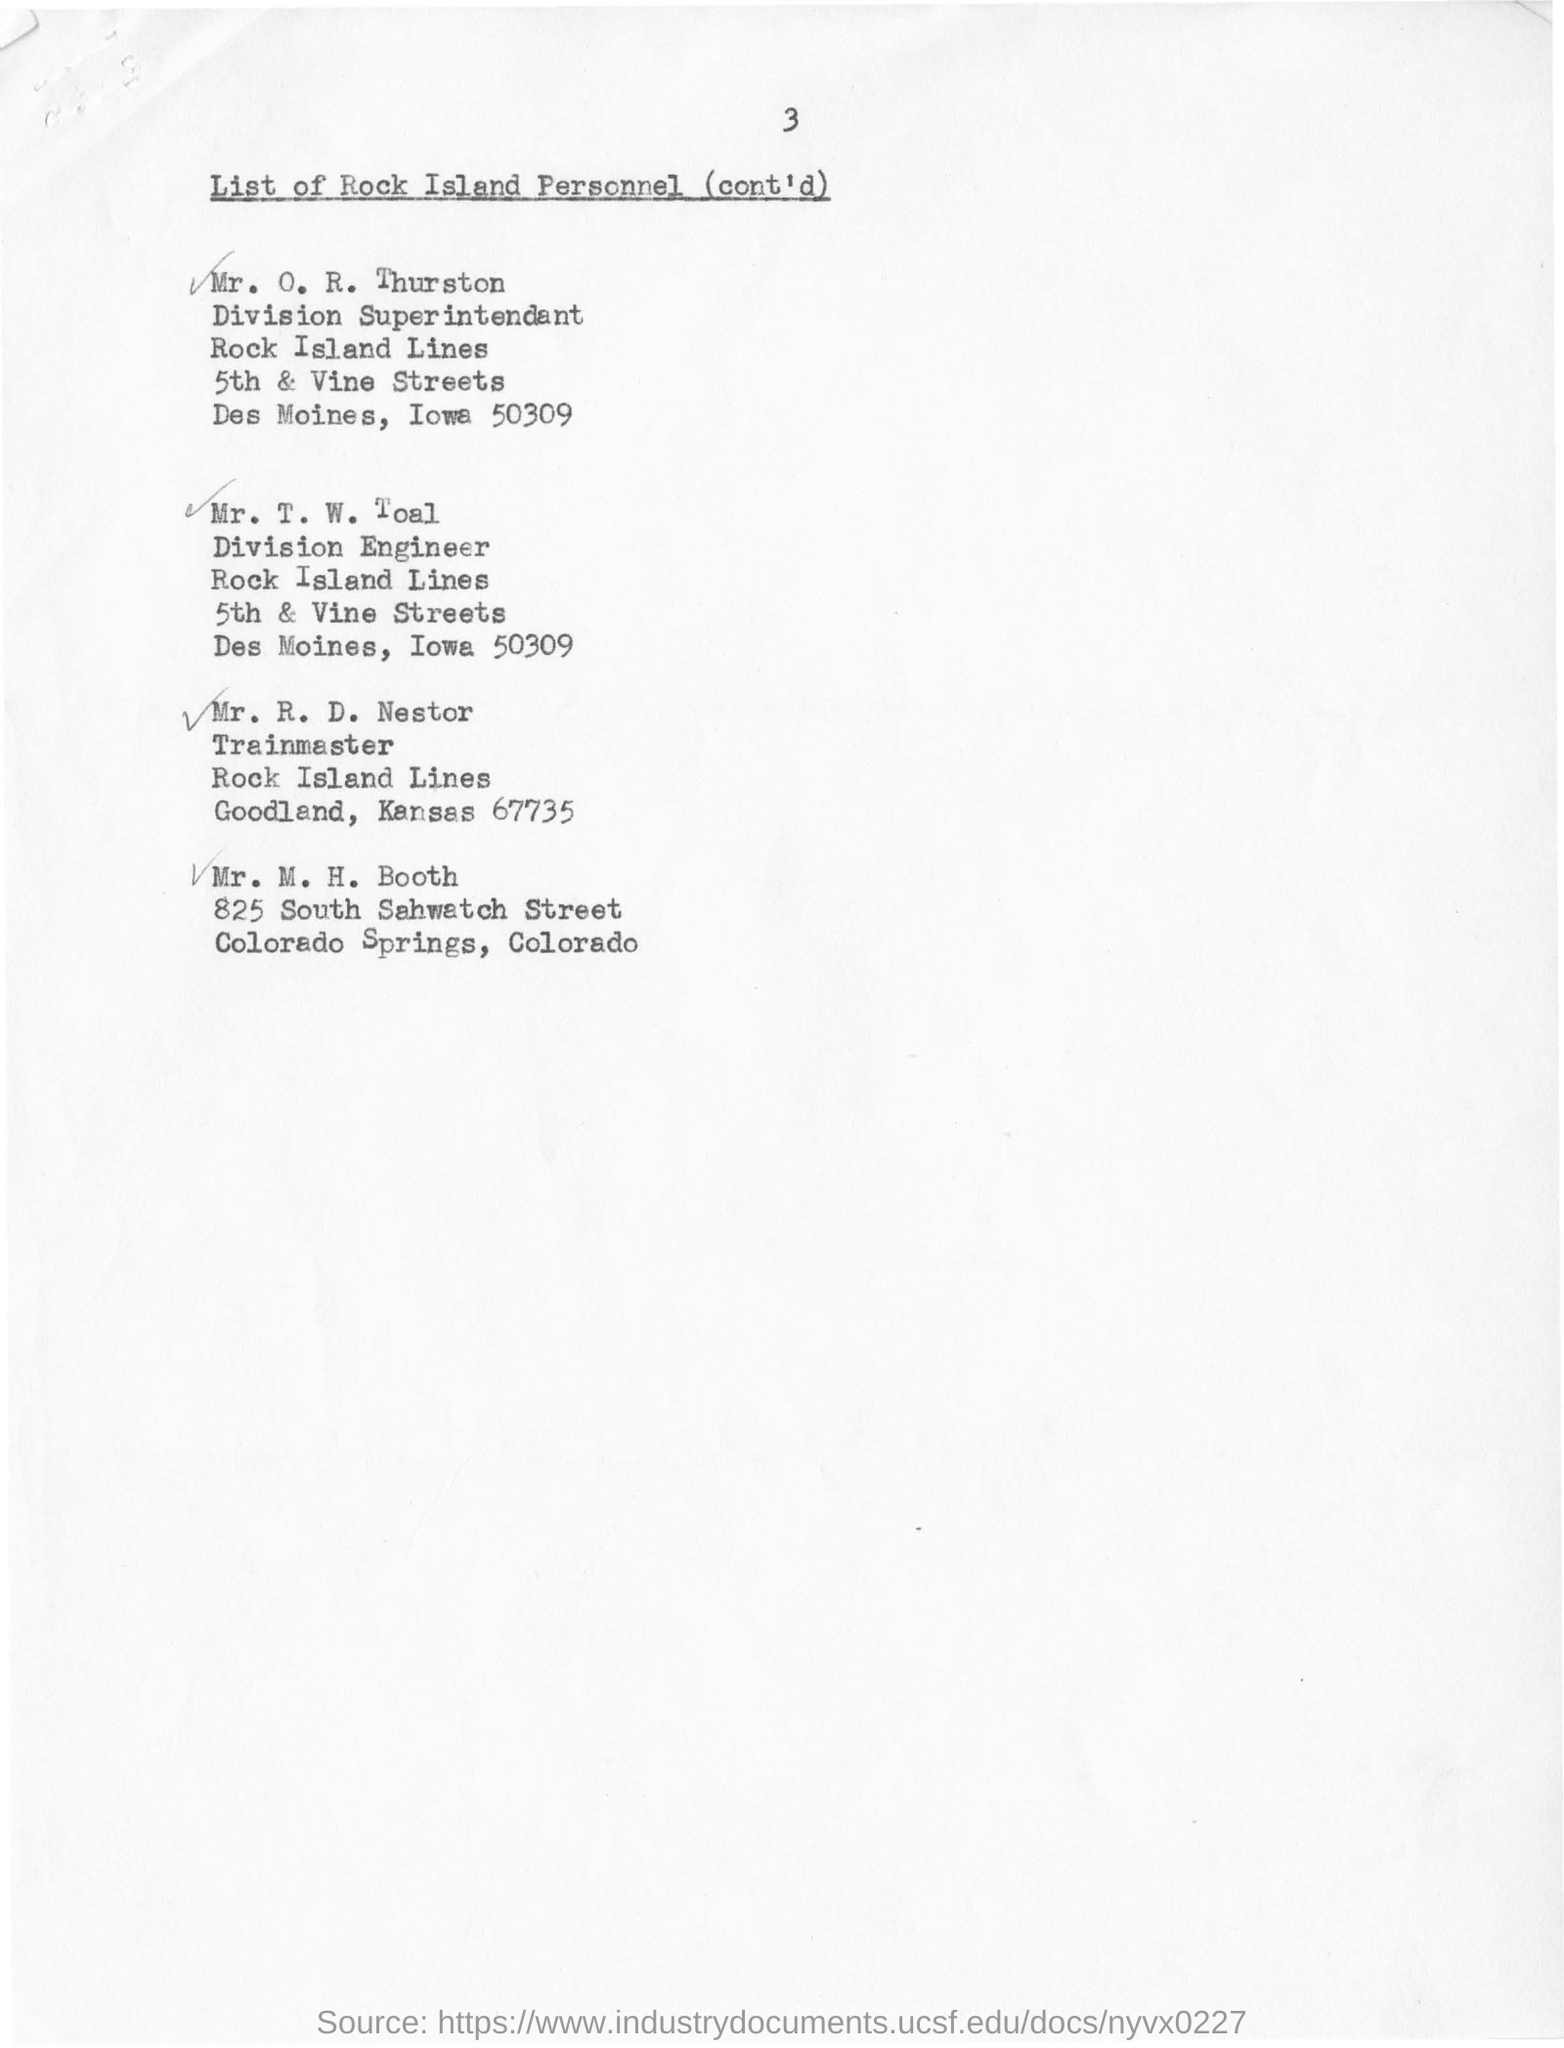Specify some key components in this picture. The train master at Rock Island Lines in Goodland, Kansas is Mr. R. D. Nestor. The individual who serves as the superintendent of the Rock Island Lines division is named Mr. O. R. Thurston. The division engineer of the Rock Island Lines is Mr. T. W. Toal. 